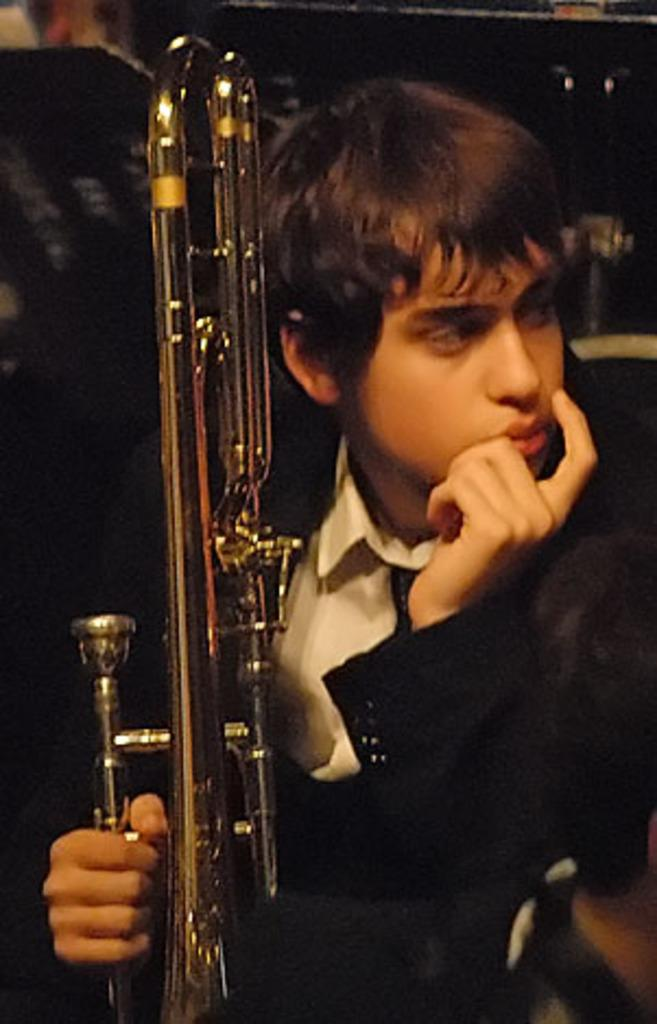What is the main subject of the image? The main subject of the image is a boy. What is the boy doing in the image? The boy is sitting in the image. What is the boy holding in the image? The boy is holding a musical instrument in the image. What type of vessel is the boy using to cook vegetables in the image? There is no vessel or vegetables present in the image; it features a boy sitting and holding a musical instrument. 